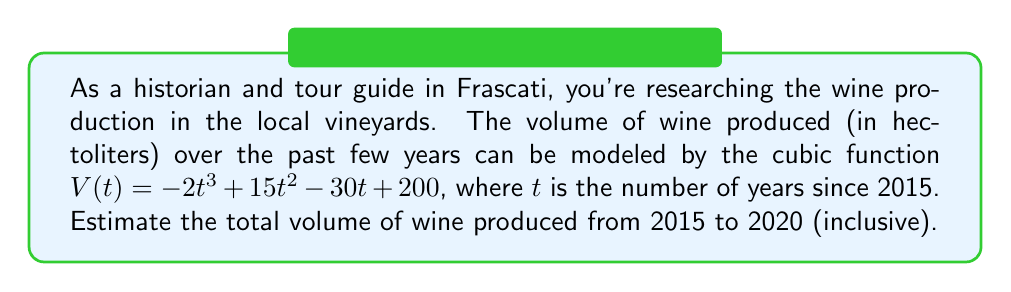Help me with this question. To solve this problem, we need to follow these steps:

1) The total volume of wine produced from 2015 to 2020 is the area under the curve of $V(t)$ from $t=0$ to $t=5$.

2) To find this area, we need to integrate the function $V(t)$ from 0 to 5:

   $$\int_0^5 V(t) dt = \int_0^5 (-2t^3 + 15t^2 - 30t + 200) dt$$

3) Integrate each term:
   
   $$\int_0^5 (-2t^3 + 15t^2 - 30t + 200) dt = \left[-\frac{1}{2}t^4 + 5t^3 - 15t^2 + 200t\right]_0^5$$

4) Evaluate the antiderivative at the upper and lower bounds:

   $$\left[-\frac{1}{2}(5^4) + 5(5^3) - 15(5^2) + 200(5)\right] - \left[-\frac{1}{2}(0^4) + 5(0^3) - 15(0^2) + 200(0)\right]$$

5) Simplify:

   $$\left[-312.5 + 625 - 375 + 1000\right] - [0]$$
   
   $$= 937.5$$

6) Since the volume is in hectoliters and we're estimating, we can round to the nearest whole number.
Answer: The estimated total volume of wine produced in Frascati vineyards from 2015 to 2020 is approximately 938 hectoliters. 